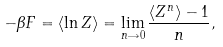<formula> <loc_0><loc_0><loc_500><loc_500>- \beta F = \langle \ln Z \rangle = \lim _ { n \rightarrow 0 } \frac { \langle Z ^ { n } \rangle - 1 } { n } ,</formula> 